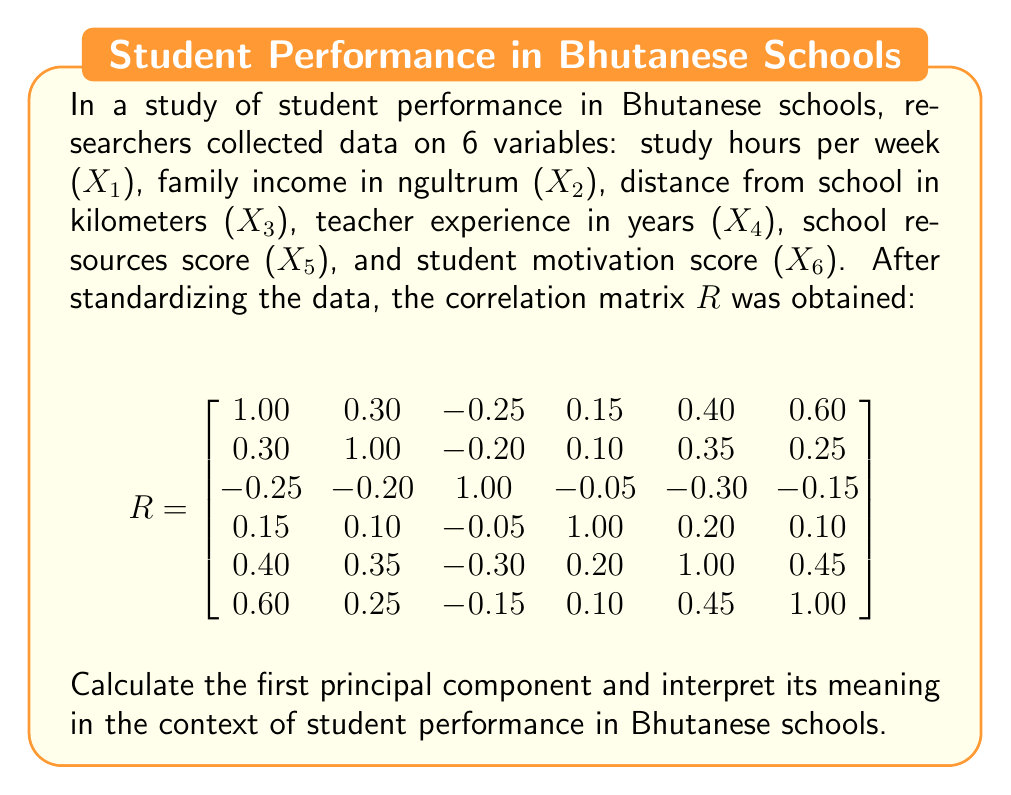Can you answer this question? To find the first principal component, we need to follow these steps:

1. Calculate the eigenvalues and eigenvectors of the correlation matrix R.
2. The eigenvector corresponding to the largest eigenvalue is the first principal component.
3. Interpret the coefficients of the eigenvector.

Step 1: Calculate eigenvalues and eigenvectors
Using a calculator or computer software, we find the eigenvalues and corresponding eigenvectors:

Eigenvalues: $\lambda_1 = 2.65$, $\lambda_2 = 1.20$, $\lambda_3 = 0.95$, $\lambda_4 = 0.60$, $\lambda_5 = 0.35$, $\lambda_6 = 0.25$

The largest eigenvalue is $\lambda_1 = 2.65$, so we focus on its corresponding eigenvector.

Step 2: First principal component
The eigenvector corresponding to $\lambda_1 = 2.65$ is:

$$
e_1 = [0.48, 0.32, -0.28, 0.15, 0.49, 0.56]^T
$$

This is the first principal component.

Step 3: Interpretation
To interpret the first principal component, we look at the magnitude and sign of each coefficient:

- X1 (study hours): 0.48 (positive, large)
- X2 (family income): 0.32 (positive, moderate)
- X3 (distance from school): -0.28 (negative, moderate)
- X4 (teacher experience): 0.15 (positive, small)
- X5 (school resources): 0.49 (positive, large)
- X6 (student motivation): 0.56 (positive, largest)

The first principal component can be interpreted as an overall measure of "academic engagement and support." It gives the most weight to student motivation, followed by school resources and study hours. Family income has a moderate positive contribution, while distance from school has a moderate negative contribution. Teacher experience has a small positive contribution.

This component suggests that students who are highly motivated, have access to good school resources, spend more time studying, come from families with higher income, and live closer to school tend to perform better academically in Bhutanese schools.
Answer: The first principal component is $e_1 = [0.48, 0.32, -0.28, 0.15, 0.49, 0.56]^T$, which can be interpreted as an overall measure of "academic engagement and support" in Bhutanese schools. It indicates that student motivation, school resources, and study hours are the most important factors influencing student performance, followed by family income and proximity to school, with teacher experience having a smaller impact. 